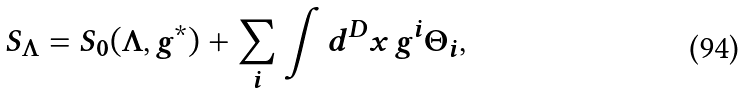Convert formula to latex. <formula><loc_0><loc_0><loc_500><loc_500>S _ { \Lambda } = S _ { 0 } ( \Lambda , g ^ { * } ) + \sum _ { i } \int d ^ { D } x \, g ^ { i } \Theta _ { i } ,</formula> 